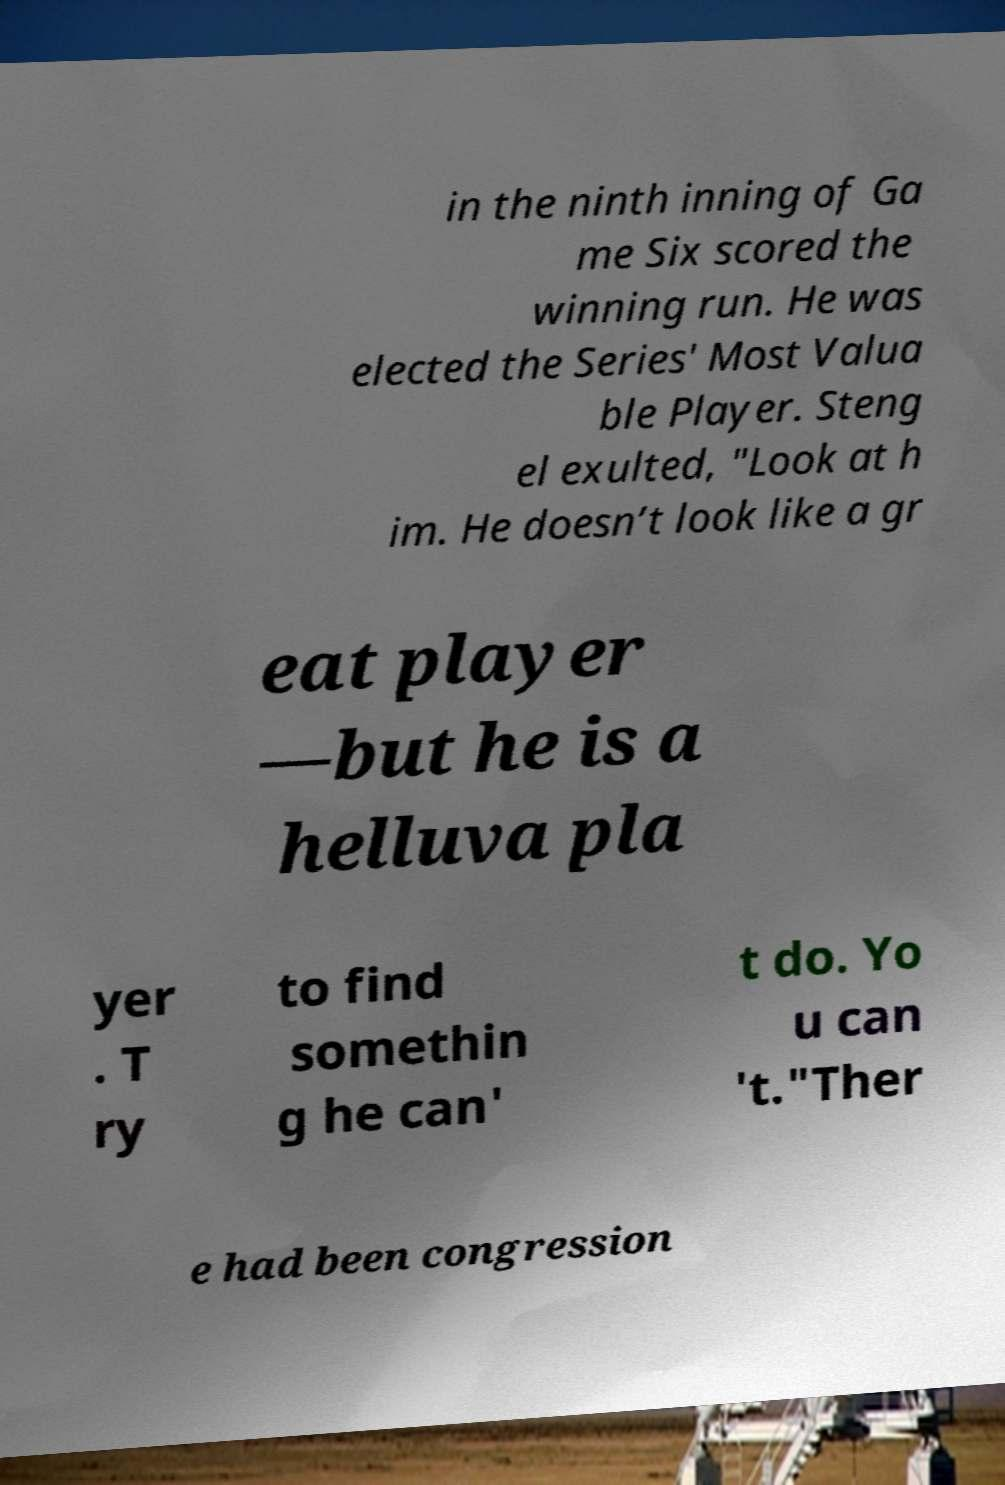For documentation purposes, I need the text within this image transcribed. Could you provide that? in the ninth inning of Ga me Six scored the winning run. He was elected the Series' Most Valua ble Player. Steng el exulted, "Look at h im. He doesn’t look like a gr eat player —but he is a helluva pla yer . T ry to find somethin g he can' t do. Yo u can 't."Ther e had been congression 